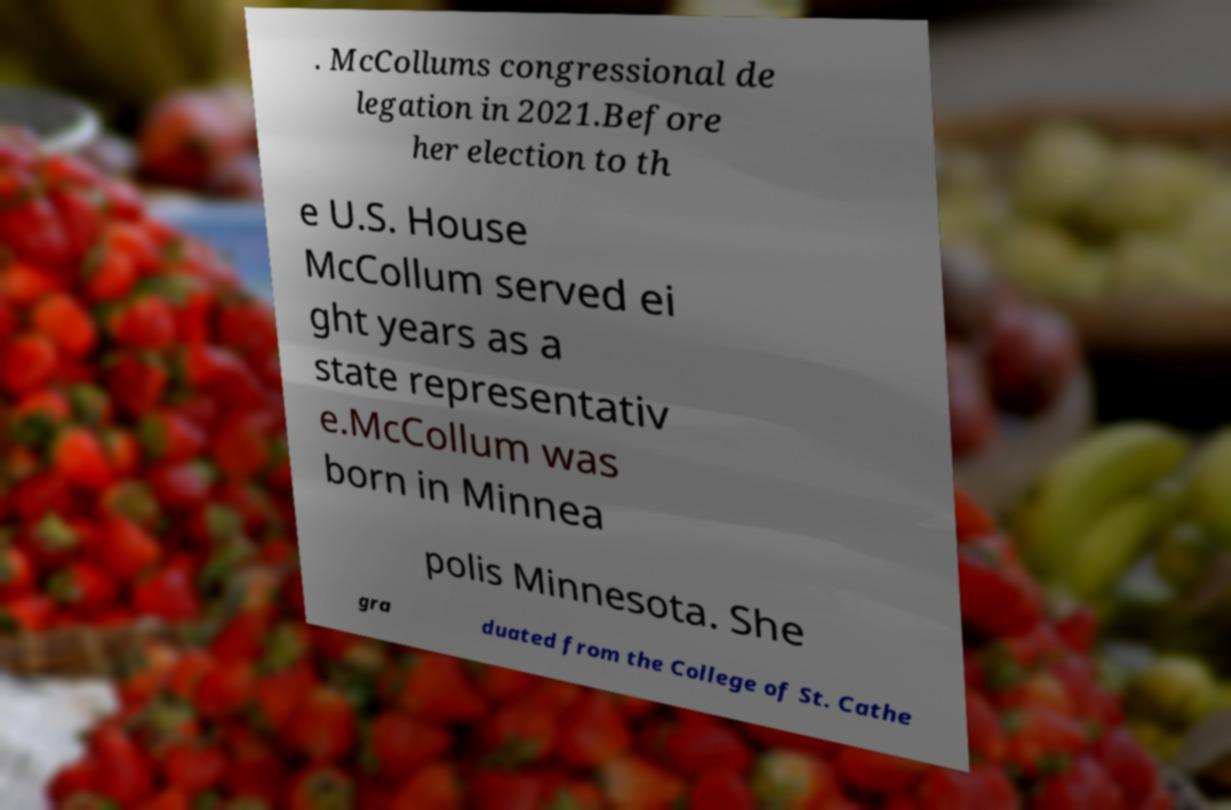Please read and relay the text visible in this image. What does it say? . McCollums congressional de legation in 2021.Before her election to th e U.S. House McCollum served ei ght years as a state representativ e.McCollum was born in Minnea polis Minnesota. She gra duated from the College of St. Cathe 